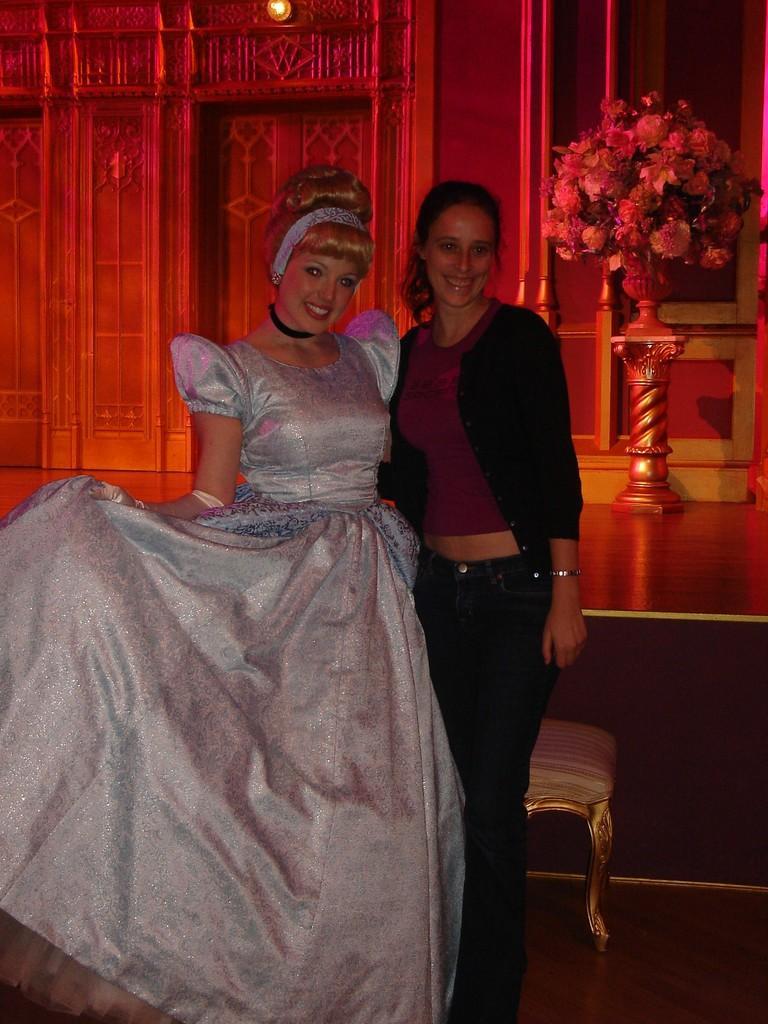Could you give a brief overview of what you see in this image? There are two women standing and smiling. This looks like a flower vase with the bunch of flowers in it. I think this is the wall. 